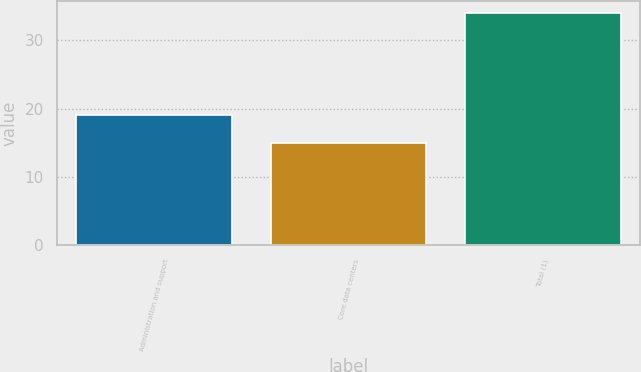<chart> <loc_0><loc_0><loc_500><loc_500><bar_chart><fcel>Administration and support<fcel>Core data centers<fcel>Total (1)<nl><fcel>19<fcel>15<fcel>34<nl></chart> 